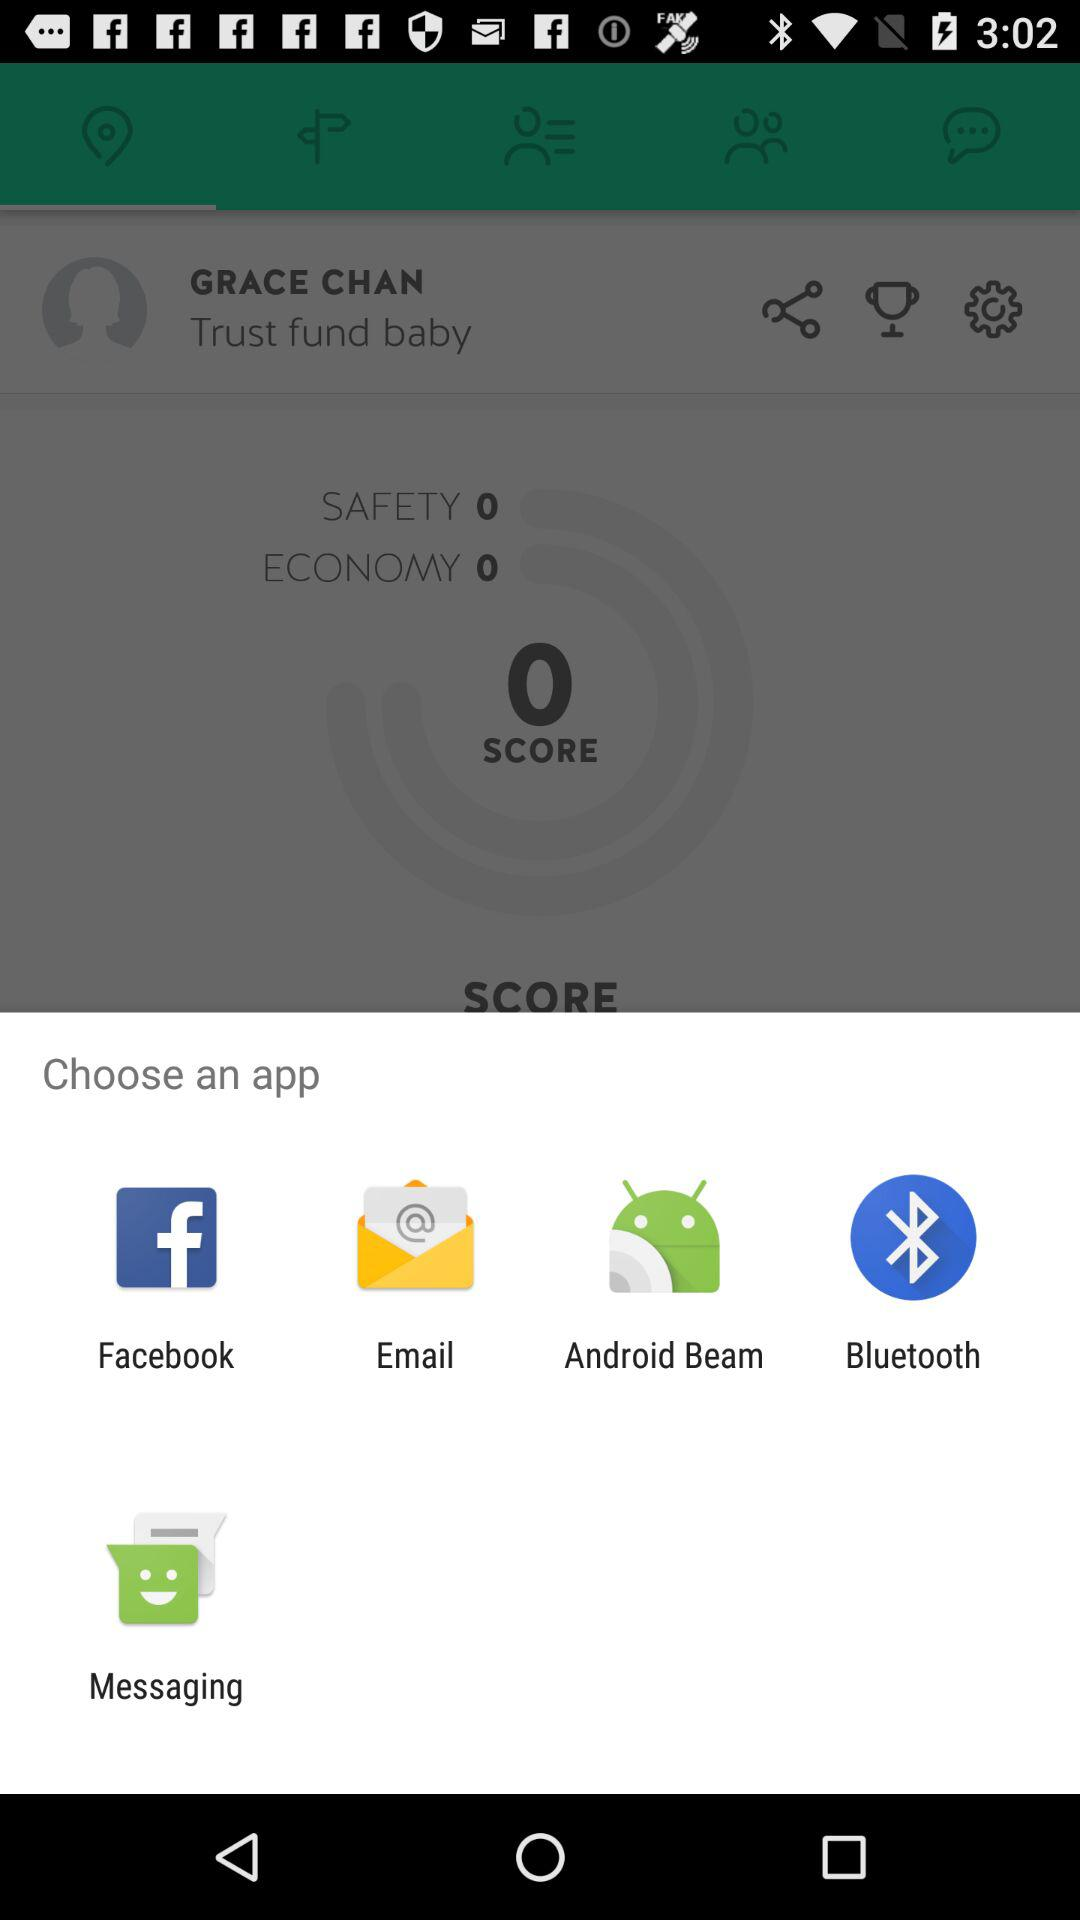Which are the applications to choose? The applications are "Facebook", "Email", "Android Beam", "Bluetooth" and "Messaging". 